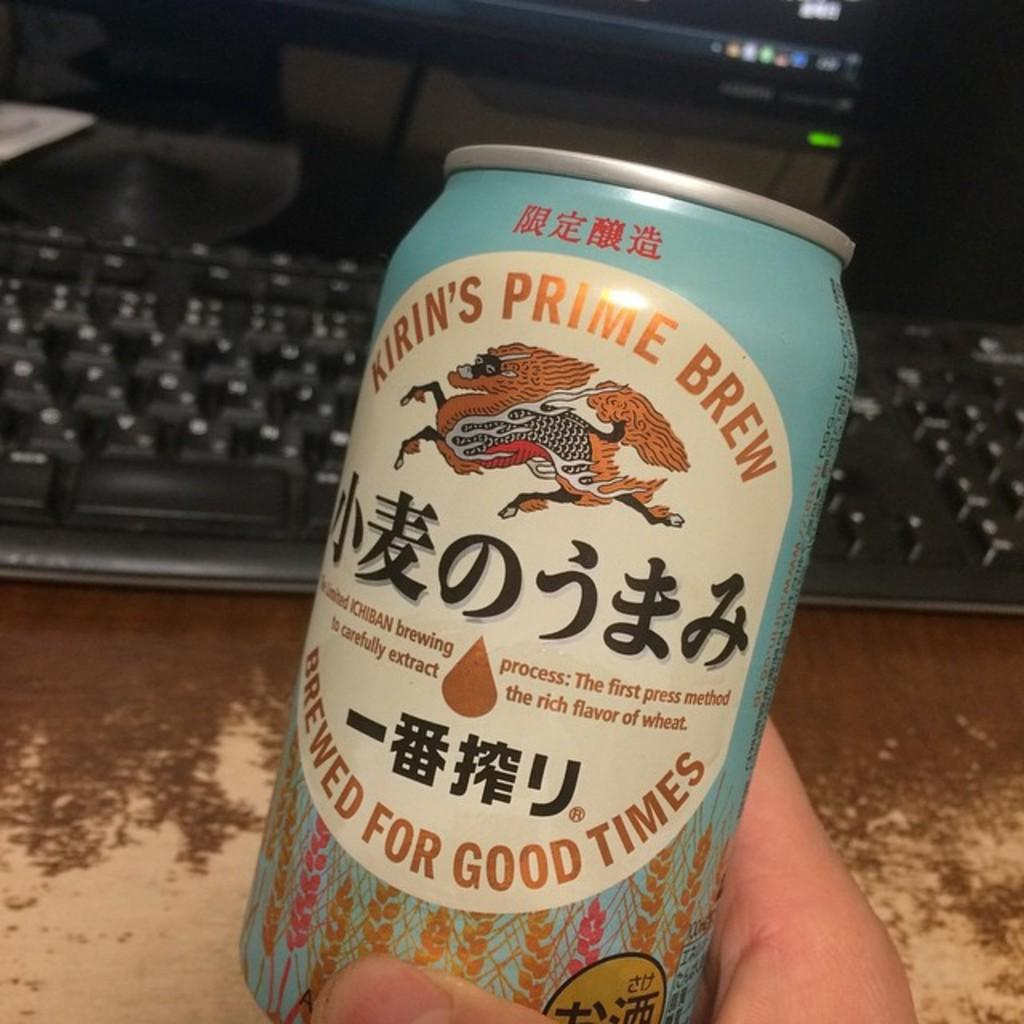<image>
Summarize the visual content of the image. A person is holding a can of Kirin's Prime Bre. 